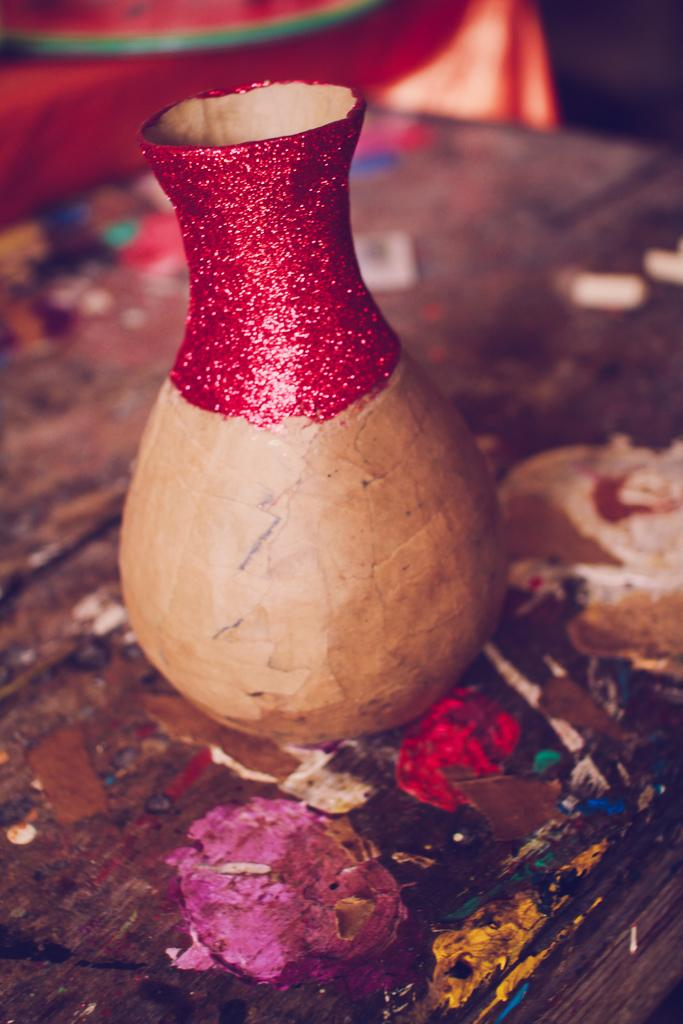What object is located at the front of the image? There is a flower vase in the front of the image. What type of surface is visible at the bottom of the image? There is a wooden surface at the bottom of the image. How would you describe the background of the image? The background of the image is blurry. What type of kite is being used in the process shown in the image? There is no kite or process present in the image; it only features a flower vase and a blurry background. 